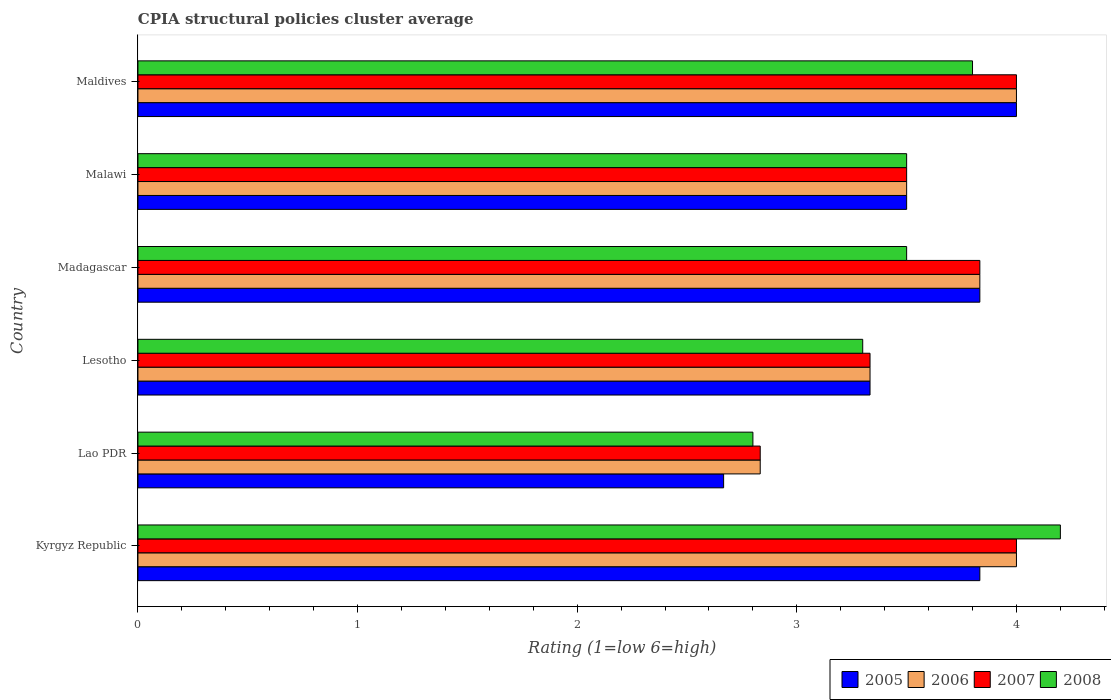How many different coloured bars are there?
Keep it short and to the point. 4. Are the number of bars on each tick of the Y-axis equal?
Your answer should be compact. Yes. How many bars are there on the 2nd tick from the top?
Provide a short and direct response. 4. How many bars are there on the 1st tick from the bottom?
Offer a terse response. 4. What is the label of the 5th group of bars from the top?
Make the answer very short. Lao PDR. Across all countries, what is the minimum CPIA rating in 2005?
Your response must be concise. 2.67. In which country was the CPIA rating in 2006 maximum?
Provide a succinct answer. Kyrgyz Republic. In which country was the CPIA rating in 2005 minimum?
Provide a succinct answer. Lao PDR. What is the total CPIA rating in 2007 in the graph?
Ensure brevity in your answer.  21.5. What is the difference between the CPIA rating in 2006 in Lao PDR and that in Madagascar?
Offer a very short reply. -1. What is the difference between the CPIA rating in 2005 in Kyrgyz Republic and the CPIA rating in 2007 in Malawi?
Ensure brevity in your answer.  0.33. What is the average CPIA rating in 2006 per country?
Ensure brevity in your answer.  3.58. What is the difference between the CPIA rating in 2005 and CPIA rating in 2007 in Lao PDR?
Ensure brevity in your answer.  -0.17. In how many countries, is the CPIA rating in 2008 greater than 0.6000000000000001 ?
Your response must be concise. 6. Is the CPIA rating in 2005 in Madagascar less than that in Malawi?
Ensure brevity in your answer.  No. Is the difference between the CPIA rating in 2005 in Lao PDR and Maldives greater than the difference between the CPIA rating in 2007 in Lao PDR and Maldives?
Offer a very short reply. No. What is the difference between the highest and the lowest CPIA rating in 2005?
Provide a short and direct response. 1.33. Is it the case that in every country, the sum of the CPIA rating in 2007 and CPIA rating in 2006 is greater than the sum of CPIA rating in 2008 and CPIA rating in 2005?
Give a very brief answer. No. What does the 3rd bar from the bottom in Lao PDR represents?
Provide a short and direct response. 2007. Is it the case that in every country, the sum of the CPIA rating in 2006 and CPIA rating in 2007 is greater than the CPIA rating in 2005?
Give a very brief answer. Yes. Are all the bars in the graph horizontal?
Provide a short and direct response. Yes. How many countries are there in the graph?
Your answer should be very brief. 6. What is the difference between two consecutive major ticks on the X-axis?
Offer a very short reply. 1. Are the values on the major ticks of X-axis written in scientific E-notation?
Provide a succinct answer. No. Does the graph contain any zero values?
Your answer should be compact. No. How many legend labels are there?
Provide a succinct answer. 4. What is the title of the graph?
Offer a terse response. CPIA structural policies cluster average. Does "1976" appear as one of the legend labels in the graph?
Your response must be concise. No. What is the label or title of the Y-axis?
Your response must be concise. Country. What is the Rating (1=low 6=high) of 2005 in Kyrgyz Republic?
Keep it short and to the point. 3.83. What is the Rating (1=low 6=high) of 2007 in Kyrgyz Republic?
Your response must be concise. 4. What is the Rating (1=low 6=high) in 2008 in Kyrgyz Republic?
Make the answer very short. 4.2. What is the Rating (1=low 6=high) of 2005 in Lao PDR?
Give a very brief answer. 2.67. What is the Rating (1=low 6=high) of 2006 in Lao PDR?
Your answer should be compact. 2.83. What is the Rating (1=low 6=high) in 2007 in Lao PDR?
Your response must be concise. 2.83. What is the Rating (1=low 6=high) in 2008 in Lao PDR?
Your answer should be compact. 2.8. What is the Rating (1=low 6=high) in 2005 in Lesotho?
Your response must be concise. 3.33. What is the Rating (1=low 6=high) of 2006 in Lesotho?
Ensure brevity in your answer.  3.33. What is the Rating (1=low 6=high) in 2007 in Lesotho?
Provide a short and direct response. 3.33. What is the Rating (1=low 6=high) in 2008 in Lesotho?
Offer a terse response. 3.3. What is the Rating (1=low 6=high) in 2005 in Madagascar?
Your answer should be compact. 3.83. What is the Rating (1=low 6=high) in 2006 in Madagascar?
Give a very brief answer. 3.83. What is the Rating (1=low 6=high) of 2007 in Madagascar?
Your answer should be compact. 3.83. What is the Rating (1=low 6=high) in 2008 in Madagascar?
Make the answer very short. 3.5. What is the Rating (1=low 6=high) of 2005 in Malawi?
Offer a terse response. 3.5. What is the Rating (1=low 6=high) of 2006 in Malawi?
Offer a very short reply. 3.5. What is the Rating (1=low 6=high) of 2007 in Malawi?
Your response must be concise. 3.5. What is the Rating (1=low 6=high) in 2008 in Malawi?
Provide a short and direct response. 3.5. What is the Rating (1=low 6=high) of 2006 in Maldives?
Give a very brief answer. 4. Across all countries, what is the maximum Rating (1=low 6=high) in 2005?
Provide a short and direct response. 4. Across all countries, what is the maximum Rating (1=low 6=high) of 2006?
Your answer should be very brief. 4. Across all countries, what is the maximum Rating (1=low 6=high) of 2008?
Keep it short and to the point. 4.2. Across all countries, what is the minimum Rating (1=low 6=high) in 2005?
Offer a very short reply. 2.67. Across all countries, what is the minimum Rating (1=low 6=high) of 2006?
Provide a short and direct response. 2.83. Across all countries, what is the minimum Rating (1=low 6=high) of 2007?
Provide a succinct answer. 2.83. Across all countries, what is the minimum Rating (1=low 6=high) of 2008?
Make the answer very short. 2.8. What is the total Rating (1=low 6=high) in 2005 in the graph?
Offer a terse response. 21.17. What is the total Rating (1=low 6=high) of 2007 in the graph?
Provide a short and direct response. 21.5. What is the total Rating (1=low 6=high) of 2008 in the graph?
Make the answer very short. 21.1. What is the difference between the Rating (1=low 6=high) in 2005 in Kyrgyz Republic and that in Lao PDR?
Your answer should be compact. 1.17. What is the difference between the Rating (1=low 6=high) in 2008 in Kyrgyz Republic and that in Lao PDR?
Offer a terse response. 1.4. What is the difference between the Rating (1=low 6=high) in 2007 in Kyrgyz Republic and that in Lesotho?
Your answer should be compact. 0.67. What is the difference between the Rating (1=low 6=high) in 2005 in Kyrgyz Republic and that in Malawi?
Ensure brevity in your answer.  0.33. What is the difference between the Rating (1=low 6=high) of 2006 in Kyrgyz Republic and that in Malawi?
Give a very brief answer. 0.5. What is the difference between the Rating (1=low 6=high) of 2007 in Kyrgyz Republic and that in Malawi?
Your answer should be very brief. 0.5. What is the difference between the Rating (1=low 6=high) of 2006 in Kyrgyz Republic and that in Maldives?
Your response must be concise. 0. What is the difference between the Rating (1=low 6=high) of 2007 in Kyrgyz Republic and that in Maldives?
Keep it short and to the point. 0. What is the difference between the Rating (1=low 6=high) in 2008 in Kyrgyz Republic and that in Maldives?
Provide a succinct answer. 0.4. What is the difference between the Rating (1=low 6=high) in 2005 in Lao PDR and that in Lesotho?
Give a very brief answer. -0.67. What is the difference between the Rating (1=low 6=high) in 2006 in Lao PDR and that in Lesotho?
Keep it short and to the point. -0.5. What is the difference between the Rating (1=low 6=high) of 2005 in Lao PDR and that in Madagascar?
Provide a succinct answer. -1.17. What is the difference between the Rating (1=low 6=high) of 2008 in Lao PDR and that in Madagascar?
Offer a very short reply. -0.7. What is the difference between the Rating (1=low 6=high) in 2005 in Lao PDR and that in Malawi?
Give a very brief answer. -0.83. What is the difference between the Rating (1=low 6=high) in 2006 in Lao PDR and that in Malawi?
Offer a very short reply. -0.67. What is the difference between the Rating (1=low 6=high) of 2007 in Lao PDR and that in Malawi?
Your answer should be compact. -0.67. What is the difference between the Rating (1=low 6=high) in 2005 in Lao PDR and that in Maldives?
Offer a terse response. -1.33. What is the difference between the Rating (1=low 6=high) of 2006 in Lao PDR and that in Maldives?
Your answer should be compact. -1.17. What is the difference between the Rating (1=low 6=high) in 2007 in Lao PDR and that in Maldives?
Your answer should be very brief. -1.17. What is the difference between the Rating (1=low 6=high) of 2008 in Lao PDR and that in Maldives?
Your answer should be very brief. -1. What is the difference between the Rating (1=low 6=high) in 2005 in Lesotho and that in Madagascar?
Offer a very short reply. -0.5. What is the difference between the Rating (1=low 6=high) in 2007 in Lesotho and that in Madagascar?
Your answer should be very brief. -0.5. What is the difference between the Rating (1=low 6=high) of 2008 in Lesotho and that in Madagascar?
Your response must be concise. -0.2. What is the difference between the Rating (1=low 6=high) of 2006 in Lesotho and that in Malawi?
Offer a terse response. -0.17. What is the difference between the Rating (1=low 6=high) in 2007 in Lesotho and that in Malawi?
Your response must be concise. -0.17. What is the difference between the Rating (1=low 6=high) in 2006 in Lesotho and that in Maldives?
Offer a very short reply. -0.67. What is the difference between the Rating (1=low 6=high) in 2008 in Lesotho and that in Maldives?
Provide a succinct answer. -0.5. What is the difference between the Rating (1=low 6=high) of 2005 in Madagascar and that in Malawi?
Keep it short and to the point. 0.33. What is the difference between the Rating (1=low 6=high) of 2006 in Madagascar and that in Malawi?
Give a very brief answer. 0.33. What is the difference between the Rating (1=low 6=high) of 2006 in Madagascar and that in Maldives?
Your answer should be very brief. -0.17. What is the difference between the Rating (1=low 6=high) of 2008 in Madagascar and that in Maldives?
Your answer should be very brief. -0.3. What is the difference between the Rating (1=low 6=high) in 2005 in Malawi and that in Maldives?
Make the answer very short. -0.5. What is the difference between the Rating (1=low 6=high) of 2007 in Malawi and that in Maldives?
Provide a short and direct response. -0.5. What is the difference between the Rating (1=low 6=high) of 2008 in Malawi and that in Maldives?
Your answer should be compact. -0.3. What is the difference between the Rating (1=low 6=high) of 2005 in Kyrgyz Republic and the Rating (1=low 6=high) of 2007 in Lao PDR?
Ensure brevity in your answer.  1. What is the difference between the Rating (1=low 6=high) in 2005 in Kyrgyz Republic and the Rating (1=low 6=high) in 2006 in Lesotho?
Offer a very short reply. 0.5. What is the difference between the Rating (1=low 6=high) in 2005 in Kyrgyz Republic and the Rating (1=low 6=high) in 2008 in Lesotho?
Provide a short and direct response. 0.53. What is the difference between the Rating (1=low 6=high) of 2006 in Kyrgyz Republic and the Rating (1=low 6=high) of 2007 in Lesotho?
Provide a succinct answer. 0.67. What is the difference between the Rating (1=low 6=high) in 2007 in Kyrgyz Republic and the Rating (1=low 6=high) in 2008 in Lesotho?
Provide a short and direct response. 0.7. What is the difference between the Rating (1=low 6=high) in 2005 in Kyrgyz Republic and the Rating (1=low 6=high) in 2007 in Madagascar?
Make the answer very short. 0. What is the difference between the Rating (1=low 6=high) of 2005 in Kyrgyz Republic and the Rating (1=low 6=high) of 2008 in Madagascar?
Offer a terse response. 0.33. What is the difference between the Rating (1=low 6=high) of 2006 in Kyrgyz Republic and the Rating (1=low 6=high) of 2008 in Madagascar?
Ensure brevity in your answer.  0.5. What is the difference between the Rating (1=low 6=high) of 2005 in Kyrgyz Republic and the Rating (1=low 6=high) of 2006 in Maldives?
Give a very brief answer. -0.17. What is the difference between the Rating (1=low 6=high) of 2005 in Kyrgyz Republic and the Rating (1=low 6=high) of 2008 in Maldives?
Give a very brief answer. 0.03. What is the difference between the Rating (1=low 6=high) in 2006 in Kyrgyz Republic and the Rating (1=low 6=high) in 2007 in Maldives?
Provide a succinct answer. 0. What is the difference between the Rating (1=low 6=high) in 2006 in Kyrgyz Republic and the Rating (1=low 6=high) in 2008 in Maldives?
Ensure brevity in your answer.  0.2. What is the difference between the Rating (1=low 6=high) in 2005 in Lao PDR and the Rating (1=low 6=high) in 2006 in Lesotho?
Provide a short and direct response. -0.67. What is the difference between the Rating (1=low 6=high) of 2005 in Lao PDR and the Rating (1=low 6=high) of 2008 in Lesotho?
Your answer should be compact. -0.63. What is the difference between the Rating (1=low 6=high) of 2006 in Lao PDR and the Rating (1=low 6=high) of 2008 in Lesotho?
Keep it short and to the point. -0.47. What is the difference between the Rating (1=low 6=high) of 2007 in Lao PDR and the Rating (1=low 6=high) of 2008 in Lesotho?
Keep it short and to the point. -0.47. What is the difference between the Rating (1=low 6=high) in 2005 in Lao PDR and the Rating (1=low 6=high) in 2006 in Madagascar?
Make the answer very short. -1.17. What is the difference between the Rating (1=low 6=high) of 2005 in Lao PDR and the Rating (1=low 6=high) of 2007 in Madagascar?
Your answer should be very brief. -1.17. What is the difference between the Rating (1=low 6=high) in 2005 in Lao PDR and the Rating (1=low 6=high) in 2008 in Madagascar?
Offer a very short reply. -0.83. What is the difference between the Rating (1=low 6=high) of 2006 in Lao PDR and the Rating (1=low 6=high) of 2007 in Madagascar?
Your answer should be compact. -1. What is the difference between the Rating (1=low 6=high) in 2007 in Lao PDR and the Rating (1=low 6=high) in 2008 in Madagascar?
Provide a succinct answer. -0.67. What is the difference between the Rating (1=low 6=high) of 2005 in Lao PDR and the Rating (1=low 6=high) of 2008 in Malawi?
Your answer should be very brief. -0.83. What is the difference between the Rating (1=low 6=high) in 2007 in Lao PDR and the Rating (1=low 6=high) in 2008 in Malawi?
Your answer should be very brief. -0.67. What is the difference between the Rating (1=low 6=high) in 2005 in Lao PDR and the Rating (1=low 6=high) in 2006 in Maldives?
Make the answer very short. -1.33. What is the difference between the Rating (1=low 6=high) of 2005 in Lao PDR and the Rating (1=low 6=high) of 2007 in Maldives?
Provide a succinct answer. -1.33. What is the difference between the Rating (1=low 6=high) of 2005 in Lao PDR and the Rating (1=low 6=high) of 2008 in Maldives?
Give a very brief answer. -1.13. What is the difference between the Rating (1=low 6=high) of 2006 in Lao PDR and the Rating (1=low 6=high) of 2007 in Maldives?
Keep it short and to the point. -1.17. What is the difference between the Rating (1=low 6=high) in 2006 in Lao PDR and the Rating (1=low 6=high) in 2008 in Maldives?
Ensure brevity in your answer.  -0.97. What is the difference between the Rating (1=low 6=high) in 2007 in Lao PDR and the Rating (1=low 6=high) in 2008 in Maldives?
Your answer should be very brief. -0.97. What is the difference between the Rating (1=low 6=high) of 2005 in Lesotho and the Rating (1=low 6=high) of 2006 in Malawi?
Your response must be concise. -0.17. What is the difference between the Rating (1=low 6=high) in 2005 in Lesotho and the Rating (1=low 6=high) in 2007 in Malawi?
Offer a terse response. -0.17. What is the difference between the Rating (1=low 6=high) in 2005 in Lesotho and the Rating (1=low 6=high) in 2008 in Malawi?
Provide a short and direct response. -0.17. What is the difference between the Rating (1=low 6=high) of 2006 in Lesotho and the Rating (1=low 6=high) of 2007 in Malawi?
Your answer should be compact. -0.17. What is the difference between the Rating (1=low 6=high) of 2006 in Lesotho and the Rating (1=low 6=high) of 2008 in Malawi?
Make the answer very short. -0.17. What is the difference between the Rating (1=low 6=high) in 2005 in Lesotho and the Rating (1=low 6=high) in 2007 in Maldives?
Offer a terse response. -0.67. What is the difference between the Rating (1=low 6=high) of 2005 in Lesotho and the Rating (1=low 6=high) of 2008 in Maldives?
Offer a terse response. -0.47. What is the difference between the Rating (1=low 6=high) of 2006 in Lesotho and the Rating (1=low 6=high) of 2007 in Maldives?
Your answer should be compact. -0.67. What is the difference between the Rating (1=low 6=high) of 2006 in Lesotho and the Rating (1=low 6=high) of 2008 in Maldives?
Your response must be concise. -0.47. What is the difference between the Rating (1=low 6=high) of 2007 in Lesotho and the Rating (1=low 6=high) of 2008 in Maldives?
Provide a short and direct response. -0.47. What is the difference between the Rating (1=low 6=high) in 2005 in Madagascar and the Rating (1=low 6=high) in 2006 in Malawi?
Provide a short and direct response. 0.33. What is the difference between the Rating (1=low 6=high) of 2005 in Madagascar and the Rating (1=low 6=high) of 2008 in Malawi?
Provide a short and direct response. 0.33. What is the difference between the Rating (1=low 6=high) of 2006 in Madagascar and the Rating (1=low 6=high) of 2008 in Malawi?
Your answer should be very brief. 0.33. What is the difference between the Rating (1=low 6=high) of 2005 in Madagascar and the Rating (1=low 6=high) of 2006 in Maldives?
Make the answer very short. -0.17. What is the difference between the Rating (1=low 6=high) in 2005 in Madagascar and the Rating (1=low 6=high) in 2008 in Maldives?
Provide a succinct answer. 0.03. What is the difference between the Rating (1=low 6=high) in 2005 in Malawi and the Rating (1=low 6=high) in 2007 in Maldives?
Provide a succinct answer. -0.5. What is the difference between the Rating (1=low 6=high) of 2006 in Malawi and the Rating (1=low 6=high) of 2007 in Maldives?
Your answer should be very brief. -0.5. What is the difference between the Rating (1=low 6=high) in 2006 in Malawi and the Rating (1=low 6=high) in 2008 in Maldives?
Give a very brief answer. -0.3. What is the average Rating (1=low 6=high) of 2005 per country?
Your answer should be very brief. 3.53. What is the average Rating (1=low 6=high) of 2006 per country?
Your answer should be compact. 3.58. What is the average Rating (1=low 6=high) in 2007 per country?
Ensure brevity in your answer.  3.58. What is the average Rating (1=low 6=high) in 2008 per country?
Keep it short and to the point. 3.52. What is the difference between the Rating (1=low 6=high) in 2005 and Rating (1=low 6=high) in 2006 in Kyrgyz Republic?
Give a very brief answer. -0.17. What is the difference between the Rating (1=low 6=high) of 2005 and Rating (1=low 6=high) of 2007 in Kyrgyz Republic?
Provide a short and direct response. -0.17. What is the difference between the Rating (1=low 6=high) in 2005 and Rating (1=low 6=high) in 2008 in Kyrgyz Republic?
Your answer should be very brief. -0.37. What is the difference between the Rating (1=low 6=high) of 2006 and Rating (1=low 6=high) of 2008 in Kyrgyz Republic?
Offer a very short reply. -0.2. What is the difference between the Rating (1=low 6=high) of 2005 and Rating (1=low 6=high) of 2006 in Lao PDR?
Your answer should be compact. -0.17. What is the difference between the Rating (1=low 6=high) of 2005 and Rating (1=low 6=high) of 2007 in Lao PDR?
Offer a very short reply. -0.17. What is the difference between the Rating (1=low 6=high) of 2005 and Rating (1=low 6=high) of 2008 in Lao PDR?
Keep it short and to the point. -0.13. What is the difference between the Rating (1=low 6=high) in 2006 and Rating (1=low 6=high) in 2007 in Lao PDR?
Ensure brevity in your answer.  0. What is the difference between the Rating (1=low 6=high) in 2005 and Rating (1=low 6=high) in 2006 in Lesotho?
Give a very brief answer. 0. What is the difference between the Rating (1=low 6=high) in 2005 and Rating (1=low 6=high) in 2007 in Lesotho?
Ensure brevity in your answer.  0. What is the difference between the Rating (1=low 6=high) of 2005 and Rating (1=low 6=high) of 2008 in Lesotho?
Make the answer very short. 0.03. What is the difference between the Rating (1=low 6=high) of 2006 and Rating (1=low 6=high) of 2007 in Lesotho?
Provide a succinct answer. 0. What is the difference between the Rating (1=low 6=high) in 2006 and Rating (1=low 6=high) in 2008 in Lesotho?
Give a very brief answer. 0.03. What is the difference between the Rating (1=low 6=high) in 2007 and Rating (1=low 6=high) in 2008 in Madagascar?
Your answer should be very brief. 0.33. What is the difference between the Rating (1=low 6=high) in 2005 and Rating (1=low 6=high) in 2008 in Malawi?
Keep it short and to the point. 0. What is the difference between the Rating (1=low 6=high) of 2006 and Rating (1=low 6=high) of 2007 in Malawi?
Ensure brevity in your answer.  0. What is the difference between the Rating (1=low 6=high) in 2005 and Rating (1=low 6=high) in 2007 in Maldives?
Ensure brevity in your answer.  0. What is the difference between the Rating (1=low 6=high) of 2006 and Rating (1=low 6=high) of 2007 in Maldives?
Your answer should be compact. 0. What is the difference between the Rating (1=low 6=high) of 2007 and Rating (1=low 6=high) of 2008 in Maldives?
Make the answer very short. 0.2. What is the ratio of the Rating (1=low 6=high) of 2005 in Kyrgyz Republic to that in Lao PDR?
Ensure brevity in your answer.  1.44. What is the ratio of the Rating (1=low 6=high) in 2006 in Kyrgyz Republic to that in Lao PDR?
Make the answer very short. 1.41. What is the ratio of the Rating (1=low 6=high) in 2007 in Kyrgyz Republic to that in Lao PDR?
Provide a short and direct response. 1.41. What is the ratio of the Rating (1=low 6=high) in 2008 in Kyrgyz Republic to that in Lao PDR?
Offer a terse response. 1.5. What is the ratio of the Rating (1=low 6=high) of 2005 in Kyrgyz Republic to that in Lesotho?
Ensure brevity in your answer.  1.15. What is the ratio of the Rating (1=low 6=high) in 2006 in Kyrgyz Republic to that in Lesotho?
Your response must be concise. 1.2. What is the ratio of the Rating (1=low 6=high) of 2007 in Kyrgyz Republic to that in Lesotho?
Provide a succinct answer. 1.2. What is the ratio of the Rating (1=low 6=high) in 2008 in Kyrgyz Republic to that in Lesotho?
Ensure brevity in your answer.  1.27. What is the ratio of the Rating (1=low 6=high) of 2006 in Kyrgyz Republic to that in Madagascar?
Keep it short and to the point. 1.04. What is the ratio of the Rating (1=low 6=high) in 2007 in Kyrgyz Republic to that in Madagascar?
Make the answer very short. 1.04. What is the ratio of the Rating (1=low 6=high) in 2005 in Kyrgyz Republic to that in Malawi?
Give a very brief answer. 1.1. What is the ratio of the Rating (1=low 6=high) of 2006 in Kyrgyz Republic to that in Malawi?
Provide a short and direct response. 1.14. What is the ratio of the Rating (1=low 6=high) of 2007 in Kyrgyz Republic to that in Malawi?
Provide a succinct answer. 1.14. What is the ratio of the Rating (1=low 6=high) of 2007 in Kyrgyz Republic to that in Maldives?
Provide a short and direct response. 1. What is the ratio of the Rating (1=low 6=high) in 2008 in Kyrgyz Republic to that in Maldives?
Offer a terse response. 1.11. What is the ratio of the Rating (1=low 6=high) in 2008 in Lao PDR to that in Lesotho?
Provide a short and direct response. 0.85. What is the ratio of the Rating (1=low 6=high) in 2005 in Lao PDR to that in Madagascar?
Make the answer very short. 0.7. What is the ratio of the Rating (1=low 6=high) in 2006 in Lao PDR to that in Madagascar?
Provide a succinct answer. 0.74. What is the ratio of the Rating (1=low 6=high) of 2007 in Lao PDR to that in Madagascar?
Keep it short and to the point. 0.74. What is the ratio of the Rating (1=low 6=high) of 2008 in Lao PDR to that in Madagascar?
Ensure brevity in your answer.  0.8. What is the ratio of the Rating (1=low 6=high) of 2005 in Lao PDR to that in Malawi?
Offer a terse response. 0.76. What is the ratio of the Rating (1=low 6=high) in 2006 in Lao PDR to that in Malawi?
Provide a short and direct response. 0.81. What is the ratio of the Rating (1=low 6=high) in 2007 in Lao PDR to that in Malawi?
Your answer should be very brief. 0.81. What is the ratio of the Rating (1=low 6=high) of 2005 in Lao PDR to that in Maldives?
Make the answer very short. 0.67. What is the ratio of the Rating (1=low 6=high) of 2006 in Lao PDR to that in Maldives?
Your answer should be very brief. 0.71. What is the ratio of the Rating (1=low 6=high) of 2007 in Lao PDR to that in Maldives?
Make the answer very short. 0.71. What is the ratio of the Rating (1=low 6=high) of 2008 in Lao PDR to that in Maldives?
Make the answer very short. 0.74. What is the ratio of the Rating (1=low 6=high) in 2005 in Lesotho to that in Madagascar?
Provide a succinct answer. 0.87. What is the ratio of the Rating (1=low 6=high) of 2006 in Lesotho to that in Madagascar?
Make the answer very short. 0.87. What is the ratio of the Rating (1=low 6=high) in 2007 in Lesotho to that in Madagascar?
Make the answer very short. 0.87. What is the ratio of the Rating (1=low 6=high) in 2008 in Lesotho to that in Madagascar?
Make the answer very short. 0.94. What is the ratio of the Rating (1=low 6=high) of 2005 in Lesotho to that in Malawi?
Ensure brevity in your answer.  0.95. What is the ratio of the Rating (1=low 6=high) of 2008 in Lesotho to that in Malawi?
Provide a short and direct response. 0.94. What is the ratio of the Rating (1=low 6=high) of 2005 in Lesotho to that in Maldives?
Give a very brief answer. 0.83. What is the ratio of the Rating (1=low 6=high) in 2006 in Lesotho to that in Maldives?
Give a very brief answer. 0.83. What is the ratio of the Rating (1=low 6=high) of 2008 in Lesotho to that in Maldives?
Give a very brief answer. 0.87. What is the ratio of the Rating (1=low 6=high) of 2005 in Madagascar to that in Malawi?
Give a very brief answer. 1.1. What is the ratio of the Rating (1=low 6=high) in 2006 in Madagascar to that in Malawi?
Ensure brevity in your answer.  1.1. What is the ratio of the Rating (1=low 6=high) in 2007 in Madagascar to that in Malawi?
Give a very brief answer. 1.1. What is the ratio of the Rating (1=low 6=high) of 2008 in Madagascar to that in Maldives?
Your answer should be very brief. 0.92. What is the ratio of the Rating (1=low 6=high) of 2005 in Malawi to that in Maldives?
Your answer should be compact. 0.88. What is the ratio of the Rating (1=low 6=high) in 2006 in Malawi to that in Maldives?
Keep it short and to the point. 0.88. What is the ratio of the Rating (1=low 6=high) of 2007 in Malawi to that in Maldives?
Offer a terse response. 0.88. What is the ratio of the Rating (1=low 6=high) of 2008 in Malawi to that in Maldives?
Provide a succinct answer. 0.92. What is the difference between the highest and the second highest Rating (1=low 6=high) in 2006?
Provide a succinct answer. 0. 